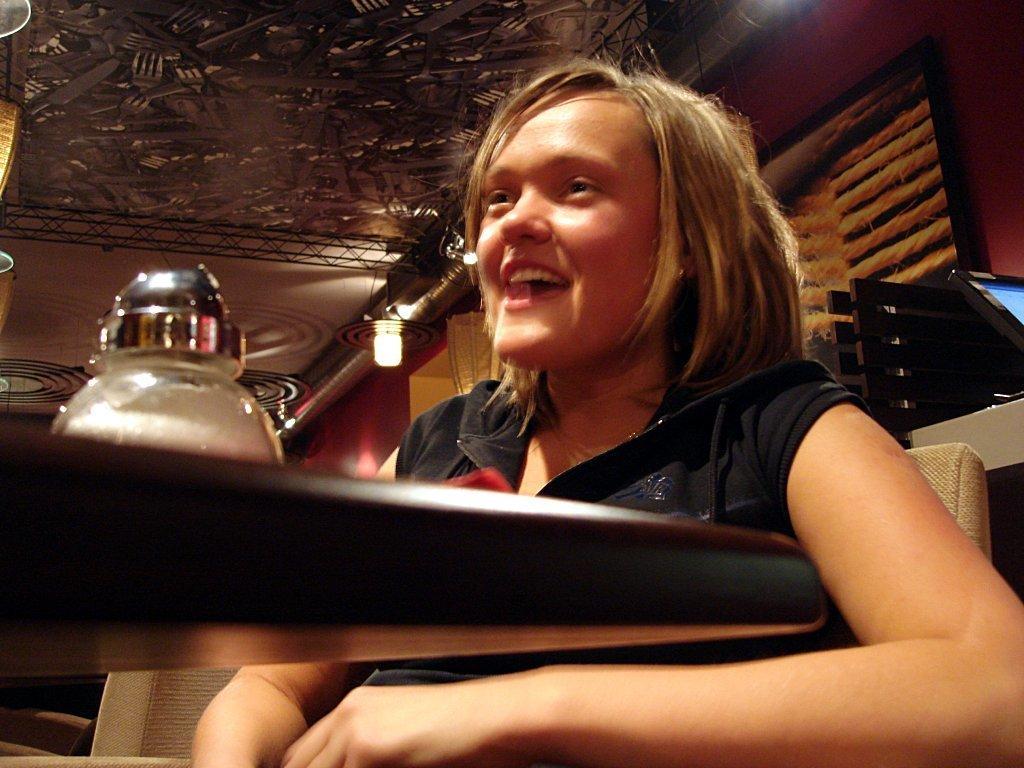Can you describe this image briefly? In this image in the foreground there is a woman, who is sitting on chair, in front of her there is a table, on which there is an object visible, at the top there is a roof , there are some lights visible in the middle. 